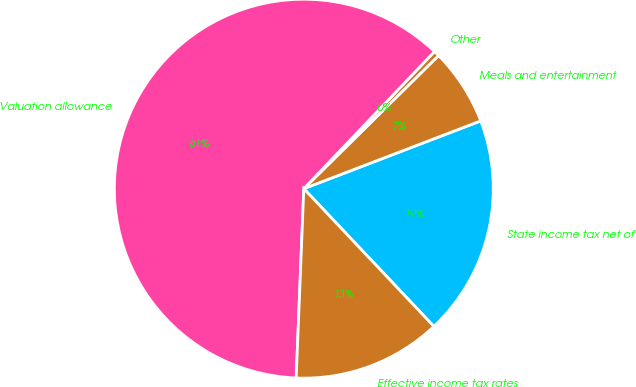<chart> <loc_0><loc_0><loc_500><loc_500><pie_chart><fcel>State income tax net of<fcel>Meals and entertainment<fcel>Other<fcel>Valuation allowance<fcel>Effective income tax rates<nl><fcel>18.78%<fcel>6.58%<fcel>0.48%<fcel>61.47%<fcel>12.68%<nl></chart> 